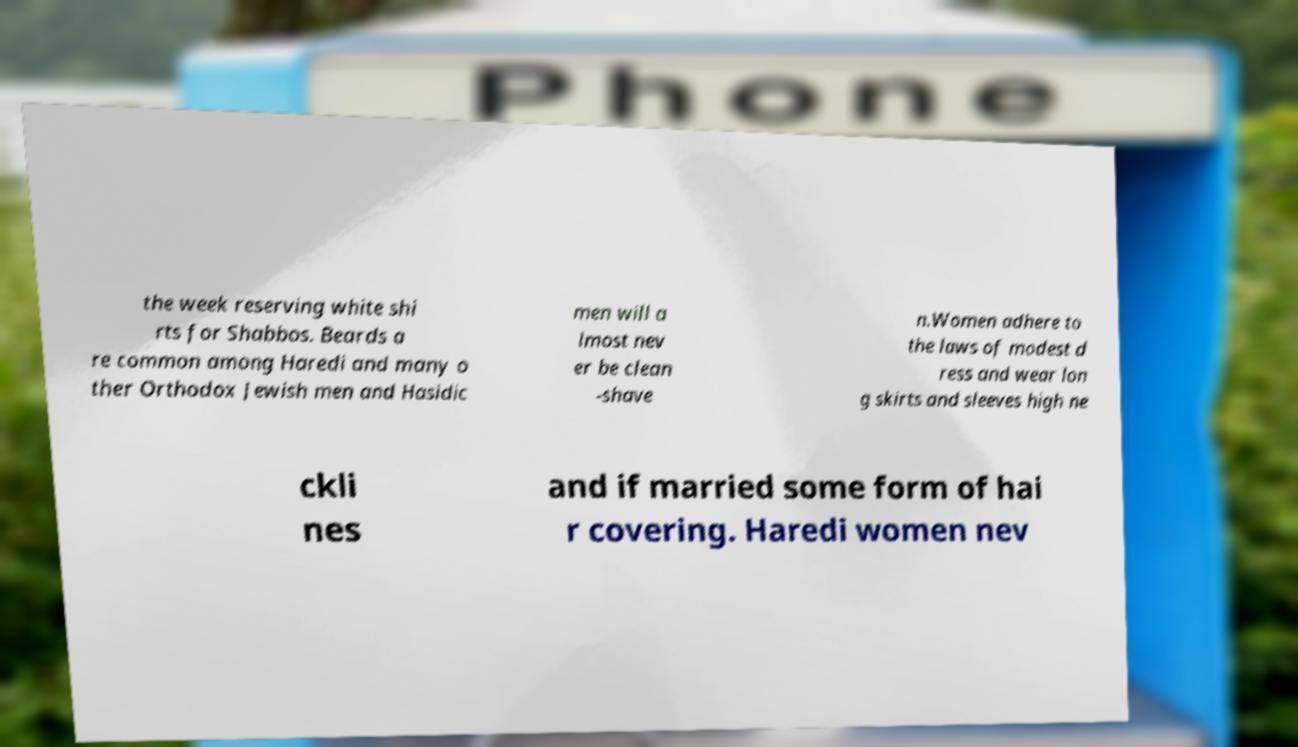Can you accurately transcribe the text from the provided image for me? the week reserving white shi rts for Shabbos. Beards a re common among Haredi and many o ther Orthodox Jewish men and Hasidic men will a lmost nev er be clean -shave n.Women adhere to the laws of modest d ress and wear lon g skirts and sleeves high ne ckli nes and if married some form of hai r covering. Haredi women nev 